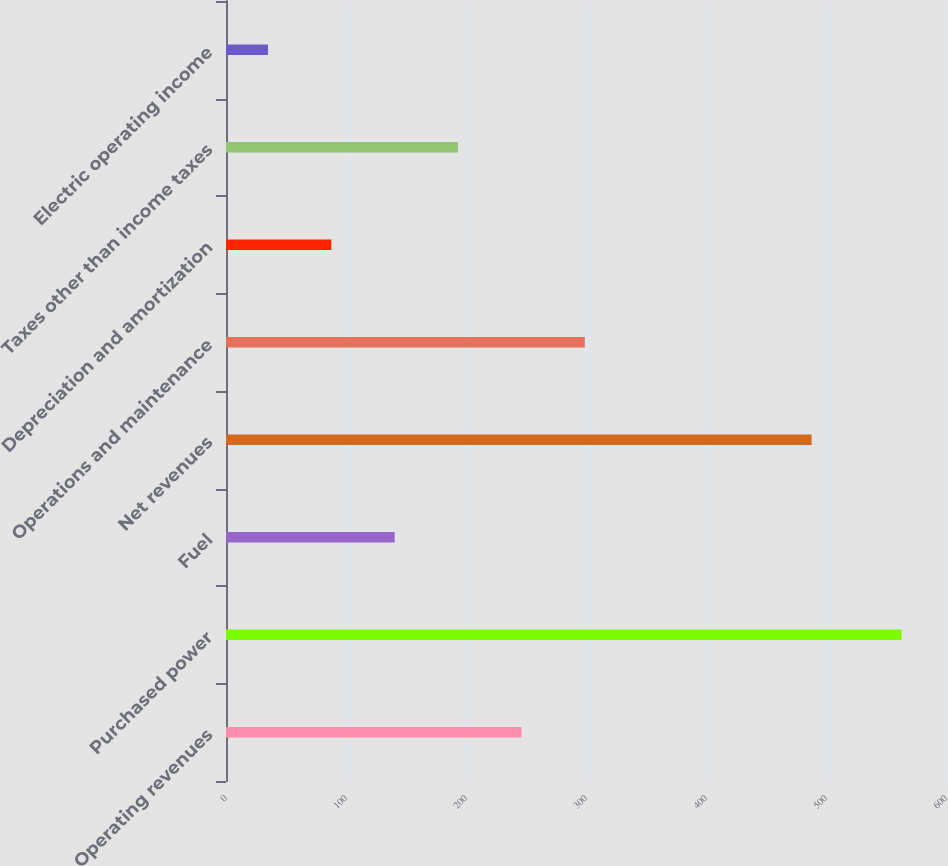Convert chart to OTSL. <chart><loc_0><loc_0><loc_500><loc_500><bar_chart><fcel>Operating revenues<fcel>Purchased power<fcel>Fuel<fcel>Net revenues<fcel>Operations and maintenance<fcel>Depreciation and amortization<fcel>Taxes other than income taxes<fcel>Electric operating income<nl><fcel>246.2<fcel>563<fcel>140.6<fcel>488<fcel>299<fcel>87.8<fcel>193.4<fcel>35<nl></chart> 